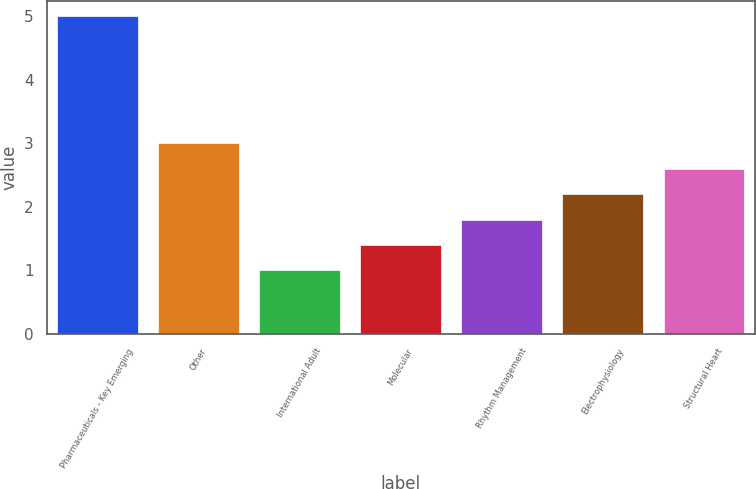<chart> <loc_0><loc_0><loc_500><loc_500><bar_chart><fcel>Pharmaceuticals - Key Emerging<fcel>Other<fcel>International Adult<fcel>Molecular<fcel>Rhythm Management<fcel>Electrophysiology<fcel>Structural Heart<nl><fcel>5<fcel>3<fcel>1<fcel>1.4<fcel>1.8<fcel>2.2<fcel>2.6<nl></chart> 